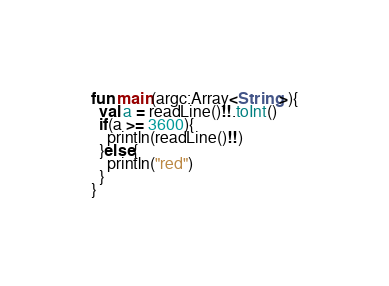<code> <loc_0><loc_0><loc_500><loc_500><_Kotlin_>fun main(argc:Array<String>){
  val a = readLine()!!.toInt()
  if(a >= 3600){
    println(readLine()!!)
  }else{
    println("red")
  }
}</code> 